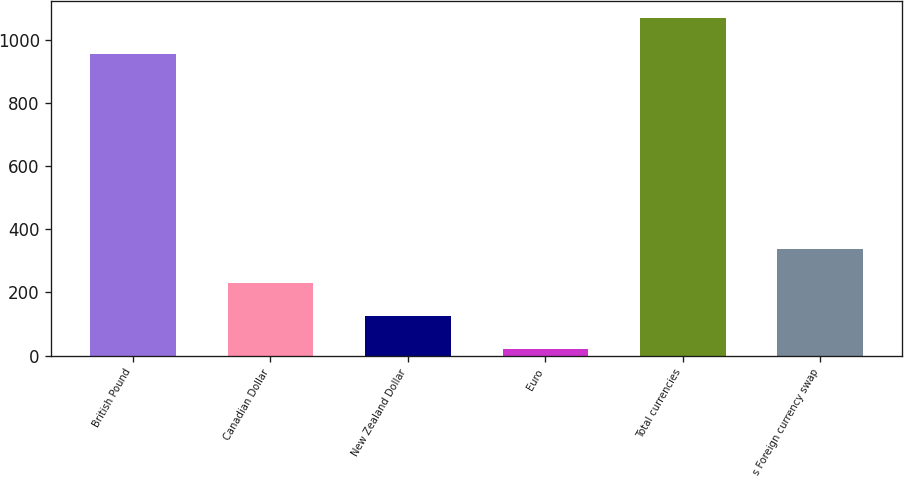Convert chart to OTSL. <chart><loc_0><loc_0><loc_500><loc_500><bar_chart><fcel>British Pound<fcel>Canadian Dollar<fcel>New Zealand Dollar<fcel>Euro<fcel>Total currencies<fcel>s Foreign currency swap<nl><fcel>955<fcel>231.4<fcel>126.7<fcel>22<fcel>1069<fcel>336.1<nl></chart> 